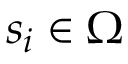Convert formula to latex. <formula><loc_0><loc_0><loc_500><loc_500>s _ { i } \in \Omega</formula> 